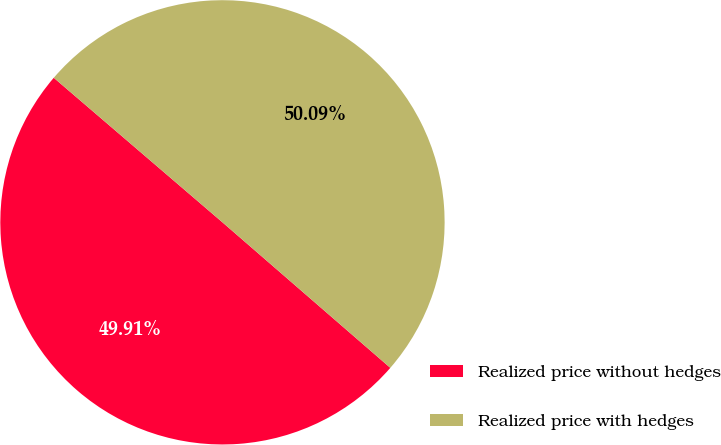<chart> <loc_0><loc_0><loc_500><loc_500><pie_chart><fcel>Realized price without hedges<fcel>Realized price with hedges<nl><fcel>49.91%<fcel>50.09%<nl></chart> 